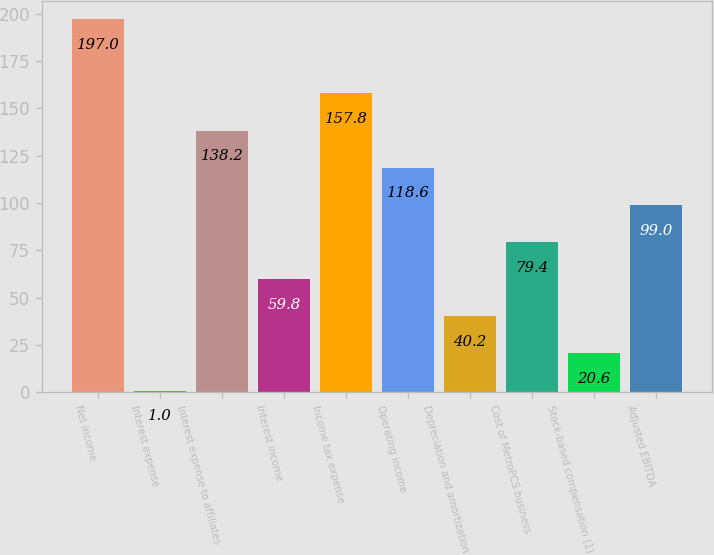<chart> <loc_0><loc_0><loc_500><loc_500><bar_chart><fcel>Net income<fcel>Interest expense<fcel>Interest expense to affiliates<fcel>Interest income<fcel>Income tax expense<fcel>Operating income<fcel>Depreciation and amortization<fcel>Cost of MetroPCS business<fcel>Stock-based compensation (1)<fcel>Adjusted EBITDA<nl><fcel>197<fcel>1<fcel>138.2<fcel>59.8<fcel>157.8<fcel>118.6<fcel>40.2<fcel>79.4<fcel>20.6<fcel>99<nl></chart> 